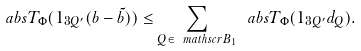<formula> <loc_0><loc_0><loc_500><loc_500>\ a b s { T _ { \Phi } ( 1 _ { 3 Q ^ { \prime } } ( b - \tilde { b } ) ) } \leq \sum _ { Q \in \ m a t h s c r { B } _ { 1 } } \ a b s { T _ { \Phi } ( 1 _ { 3 Q ^ { \prime } } d _ { Q } ) } .</formula> 